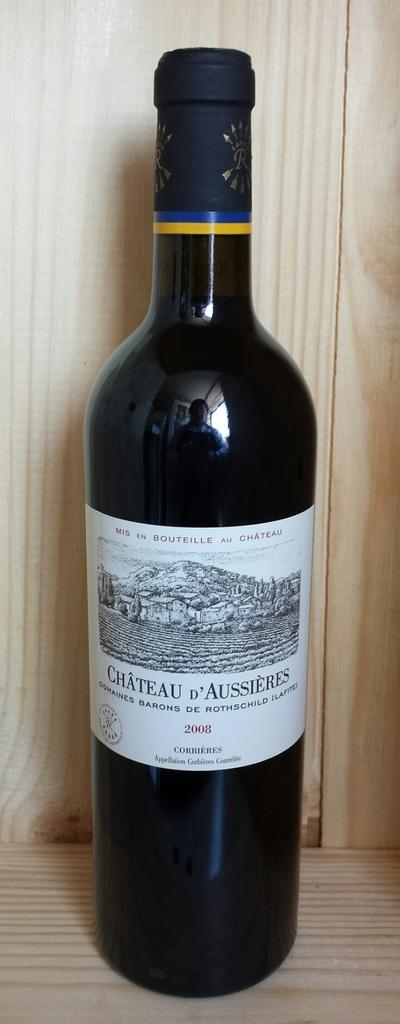<image>
Write a terse but informative summary of the picture. A bottle of Chateau D Aussieres Corbieres wine. 